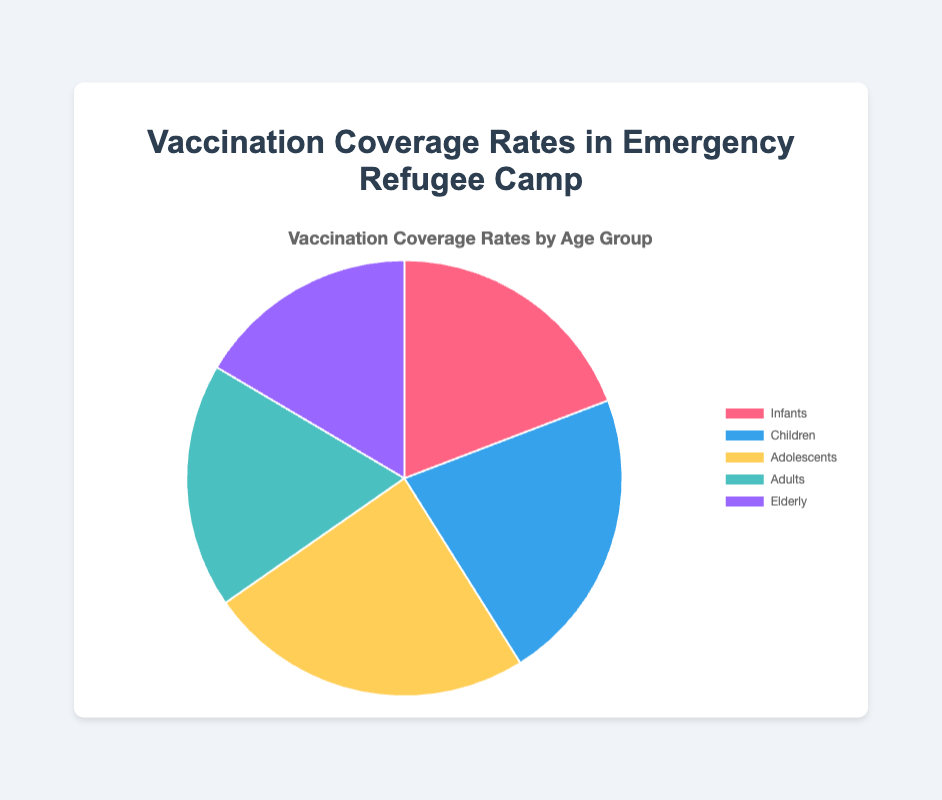What is the group with the highest vaccination coverage rate? The figure shows different coverage rates for five age groups. The group with the highest value is identifiable. Adolescents have a coverage rate of 72%, which is the highest.
Answer: Adolescents Which age group has the lowest vaccination coverage rate? By examining the values of the coverage rates in the figure, the elderly group has the lowest value at 49%.
Answer: Elderly What is the difference in vaccination coverage rates between children and adults? The coverage rate for children is 65%, and for adults, it is 54%. The difference can be calculated by subtracting 54 from 65.
Answer: 11% What is the average vaccination coverage rate for all age groups? To calculate the average, sum up the coverage rates for all groups (57 + 65 + 72 + 54 + 49 = 297) and divide by the number of groups (5). The average is 297/5.
Answer: 59.4% Are there more groups with coverage rates above or below 60%? Check each group's rate: Infants (57%), Children (65%), Adolescents (72%), Adults (54%), Elderly (49%). Count how many are above and below 60%. Three groups are below 60% (Infants, Adults, Elderly) and two are above (Children, Adolescents).
Answer: Below Which colors represent the groups Adolescents and Elderly? From the figure, the Adolescents group is represented by the third color in the dataset, and the Elderly group is represented by the fifth color. Adolescents are shown in yellow, and the Elderly in purple.
Answer: Yellow and Purple What is the combined vaccination coverage rate for Infants and Adults? Sum the vaccination coverage rates for Infants (57%) and Adults (54%). The combined rate is 57 + 54.
Answer: 111% Which age groups have vaccination coverage rates above the overall average? First, calculate the average coverage rate (59.4%). Then identify which groups have rates above this average. Children (65%) and Adolescents (72%) have rates above the average.
Answer: Children, Adolescents If the vaccination coverage rate for the Elderly is increased by 10%, what will be the new rate? The current rate for the Elderly is 49%. If increased by 10%, the new rate would be 49 + 10.
Answer: 59% What is the percentage difference between the highest and lowest vaccination coverage rates? The highest rate is 72% (Adolescents), and the lowest rate is 49% (Elderly). The percentage difference is calculated as (72 - 49).
Answer: 23% 